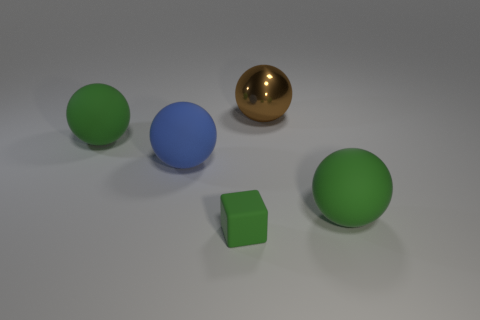How many spheres are large blue matte objects or tiny green things?
Provide a succinct answer. 1. Are there any green rubber balls that are to the right of the big green object to the right of the small green matte cube?
Provide a short and direct response. No. Is there any other thing that has the same material as the tiny green cube?
Your answer should be compact. Yes. There is a large brown thing; does it have the same shape as the big green matte object behind the blue rubber object?
Ensure brevity in your answer.  Yes. How many other things are there of the same size as the brown ball?
Ensure brevity in your answer.  3. What number of brown things are big things or large matte objects?
Make the answer very short. 1. How many big balls are both in front of the large brown object and right of the green block?
Provide a short and direct response. 1. What is the big ball behind the green rubber ball that is left of the green rubber ball that is in front of the large blue object made of?
Provide a short and direct response. Metal. What number of other big brown spheres are made of the same material as the large brown sphere?
Provide a succinct answer. 0. What shape is the blue matte object that is the same size as the metal thing?
Your answer should be very brief. Sphere. 